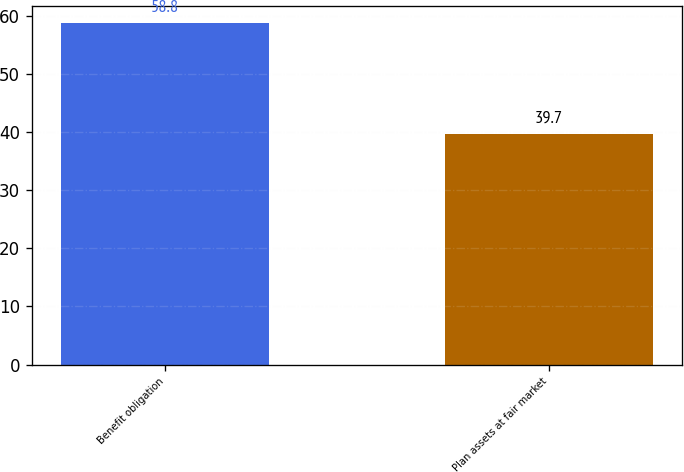<chart> <loc_0><loc_0><loc_500><loc_500><bar_chart><fcel>Benefit obligation<fcel>Plan assets at fair market<nl><fcel>58.8<fcel>39.7<nl></chart> 